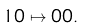<formula> <loc_0><loc_0><loc_500><loc_500>1 0 \mapsto 0 0 .</formula> 